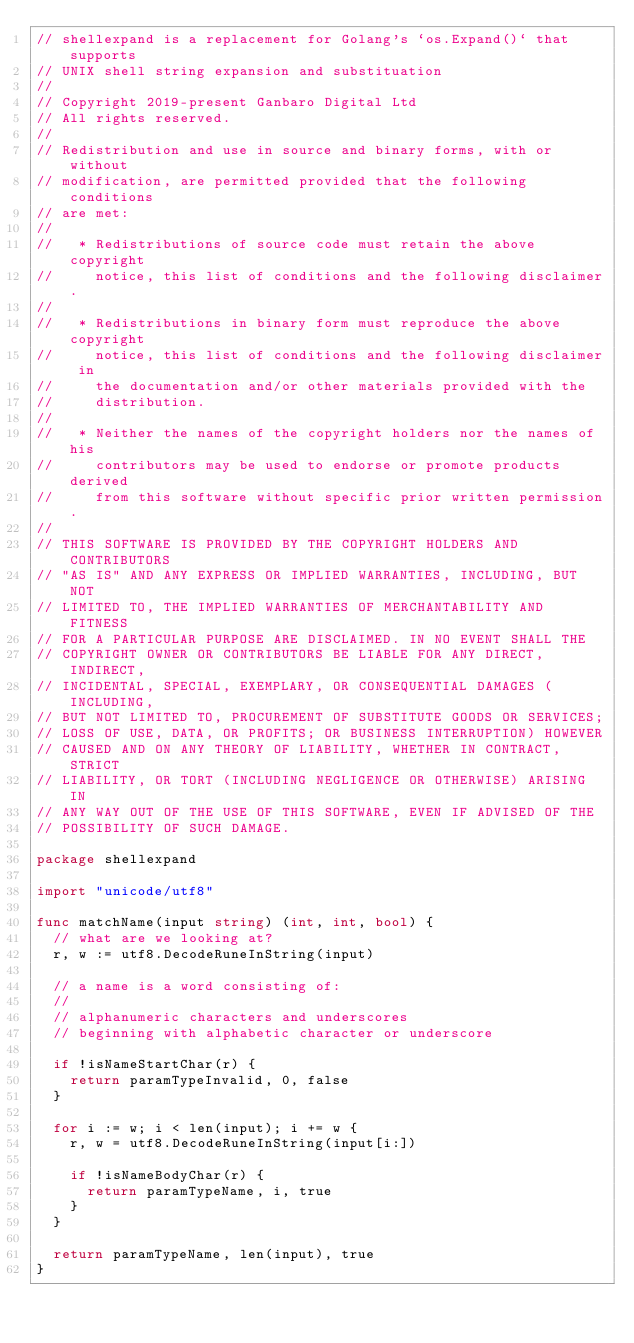<code> <loc_0><loc_0><loc_500><loc_500><_Go_>// shellexpand is a replacement for Golang's `os.Expand()` that supports
// UNIX shell string expansion and substituation
//
// Copyright 2019-present Ganbaro Digital Ltd
// All rights reserved.
//
// Redistribution and use in source and binary forms, with or without
// modification, are permitted provided that the following conditions
// are met:
//
//   * Redistributions of source code must retain the above copyright
//     notice, this list of conditions and the following disclaimer.
//
//   * Redistributions in binary form must reproduce the above copyright
//     notice, this list of conditions and the following disclaimer in
//     the documentation and/or other materials provided with the
//     distribution.
//
//   * Neither the names of the copyright holders nor the names of his
//     contributors may be used to endorse or promote products derived
//     from this software without specific prior written permission.
//
// THIS SOFTWARE IS PROVIDED BY THE COPYRIGHT HOLDERS AND CONTRIBUTORS
// "AS IS" AND ANY EXPRESS OR IMPLIED WARRANTIES, INCLUDING, BUT NOT
// LIMITED TO, THE IMPLIED WARRANTIES OF MERCHANTABILITY AND FITNESS
// FOR A PARTICULAR PURPOSE ARE DISCLAIMED. IN NO EVENT SHALL THE
// COPYRIGHT OWNER OR CONTRIBUTORS BE LIABLE FOR ANY DIRECT, INDIRECT,
// INCIDENTAL, SPECIAL, EXEMPLARY, OR CONSEQUENTIAL DAMAGES (INCLUDING,
// BUT NOT LIMITED TO, PROCUREMENT OF SUBSTITUTE GOODS OR SERVICES;
// LOSS OF USE, DATA, OR PROFITS; OR BUSINESS INTERRUPTION) HOWEVER
// CAUSED AND ON ANY THEORY OF LIABILITY, WHETHER IN CONTRACT, STRICT
// LIABILITY, OR TORT (INCLUDING NEGLIGENCE OR OTHERWISE) ARISING IN
// ANY WAY OUT OF THE USE OF THIS SOFTWARE, EVEN IF ADVISED OF THE
// POSSIBILITY OF SUCH DAMAGE.

package shellexpand

import "unicode/utf8"

func matchName(input string) (int, int, bool) {
	// what are we looking at?
	r, w := utf8.DecodeRuneInString(input)

	// a name is a word consisting of:
	//
	// alphanumeric characters and underscores
	// beginning with alphabetic character or underscore

	if !isNameStartChar(r) {
		return paramTypeInvalid, 0, false
	}

	for i := w; i < len(input); i += w {
		r, w = utf8.DecodeRuneInString(input[i:])

		if !isNameBodyChar(r) {
			return paramTypeName, i, true
		}
	}

	return paramTypeName, len(input), true
}
</code> 